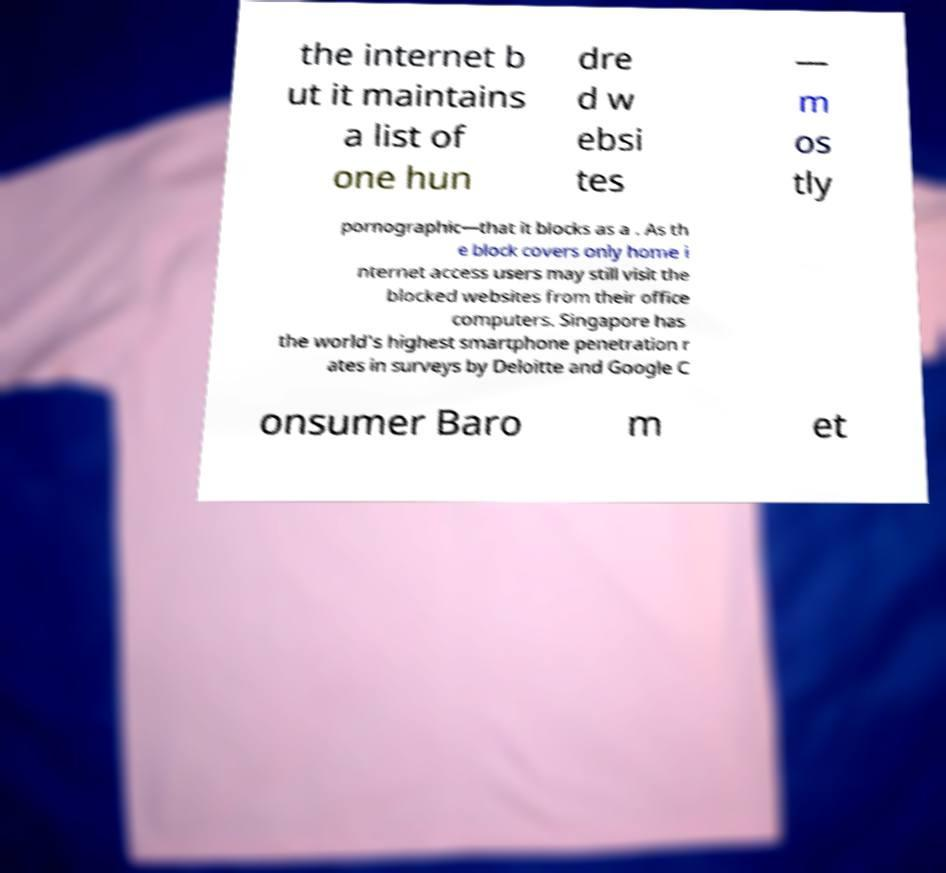Can you accurately transcribe the text from the provided image for me? the internet b ut it maintains a list of one hun dre d w ebsi tes — m os tly pornographic—that it blocks as a . As th e block covers only home i nternet access users may still visit the blocked websites from their office computers. Singapore has the world's highest smartphone penetration r ates in surveys by Deloitte and Google C onsumer Baro m et 